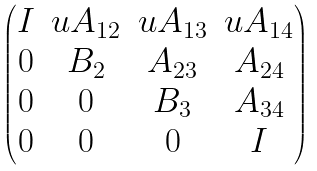Convert formula to latex. <formula><loc_0><loc_0><loc_500><loc_500>\begin{pmatrix} I & u A _ { 1 2 } & u A _ { 1 3 } & u A _ { 1 4 } \\ 0 & B _ { 2 } & A _ { 2 3 } & A _ { 2 4 } \\ 0 & 0 & B _ { 3 } & A _ { 3 4 } \\ 0 & 0 & 0 & I \\ \end{pmatrix}</formula> 